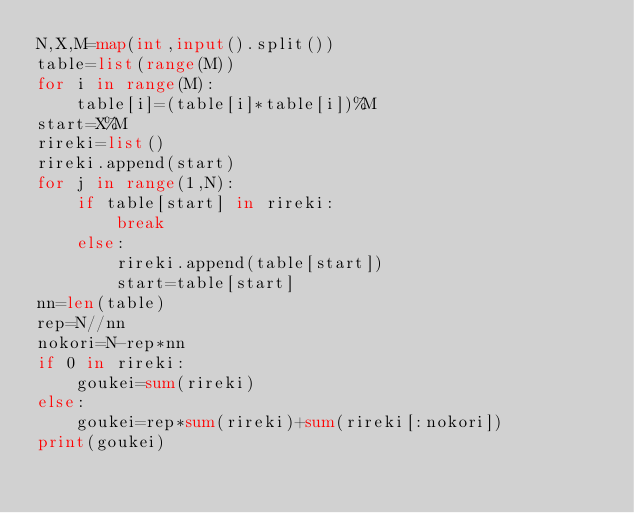Convert code to text. <code><loc_0><loc_0><loc_500><loc_500><_Python_>N,X,M=map(int,input().split())
table=list(range(M))
for i in range(M):
    table[i]=(table[i]*table[i])%M
start=X%M
rireki=list()
rireki.append(start)
for j in range(1,N):
    if table[start] in rireki:
        break
    else:
        rireki.append(table[start])
        start=table[start]
nn=len(table)
rep=N//nn
nokori=N-rep*nn
if 0 in rireki:
    goukei=sum(rireki)
else:
    goukei=rep*sum(rireki)+sum(rireki[:nokori])
print(goukei)



</code> 